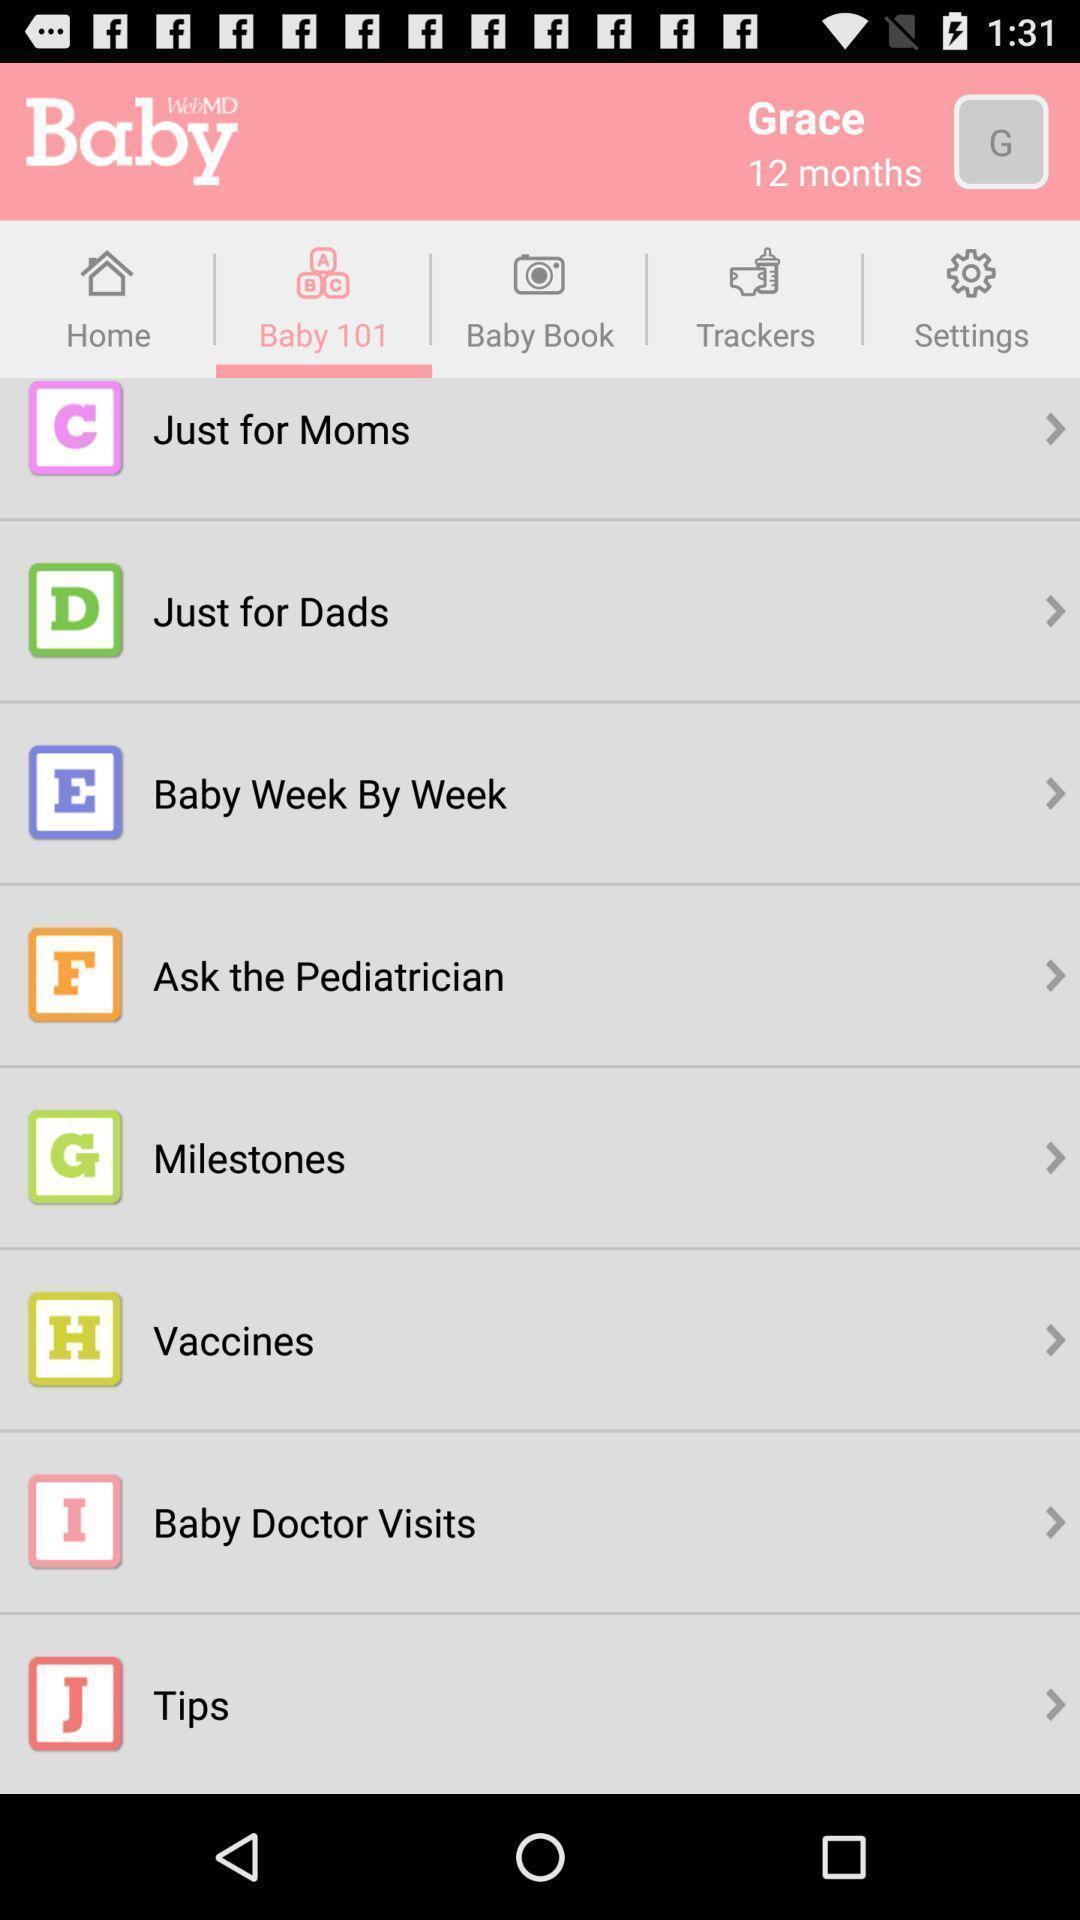Tell me about the visual elements in this screen capture. Screen showing options. 